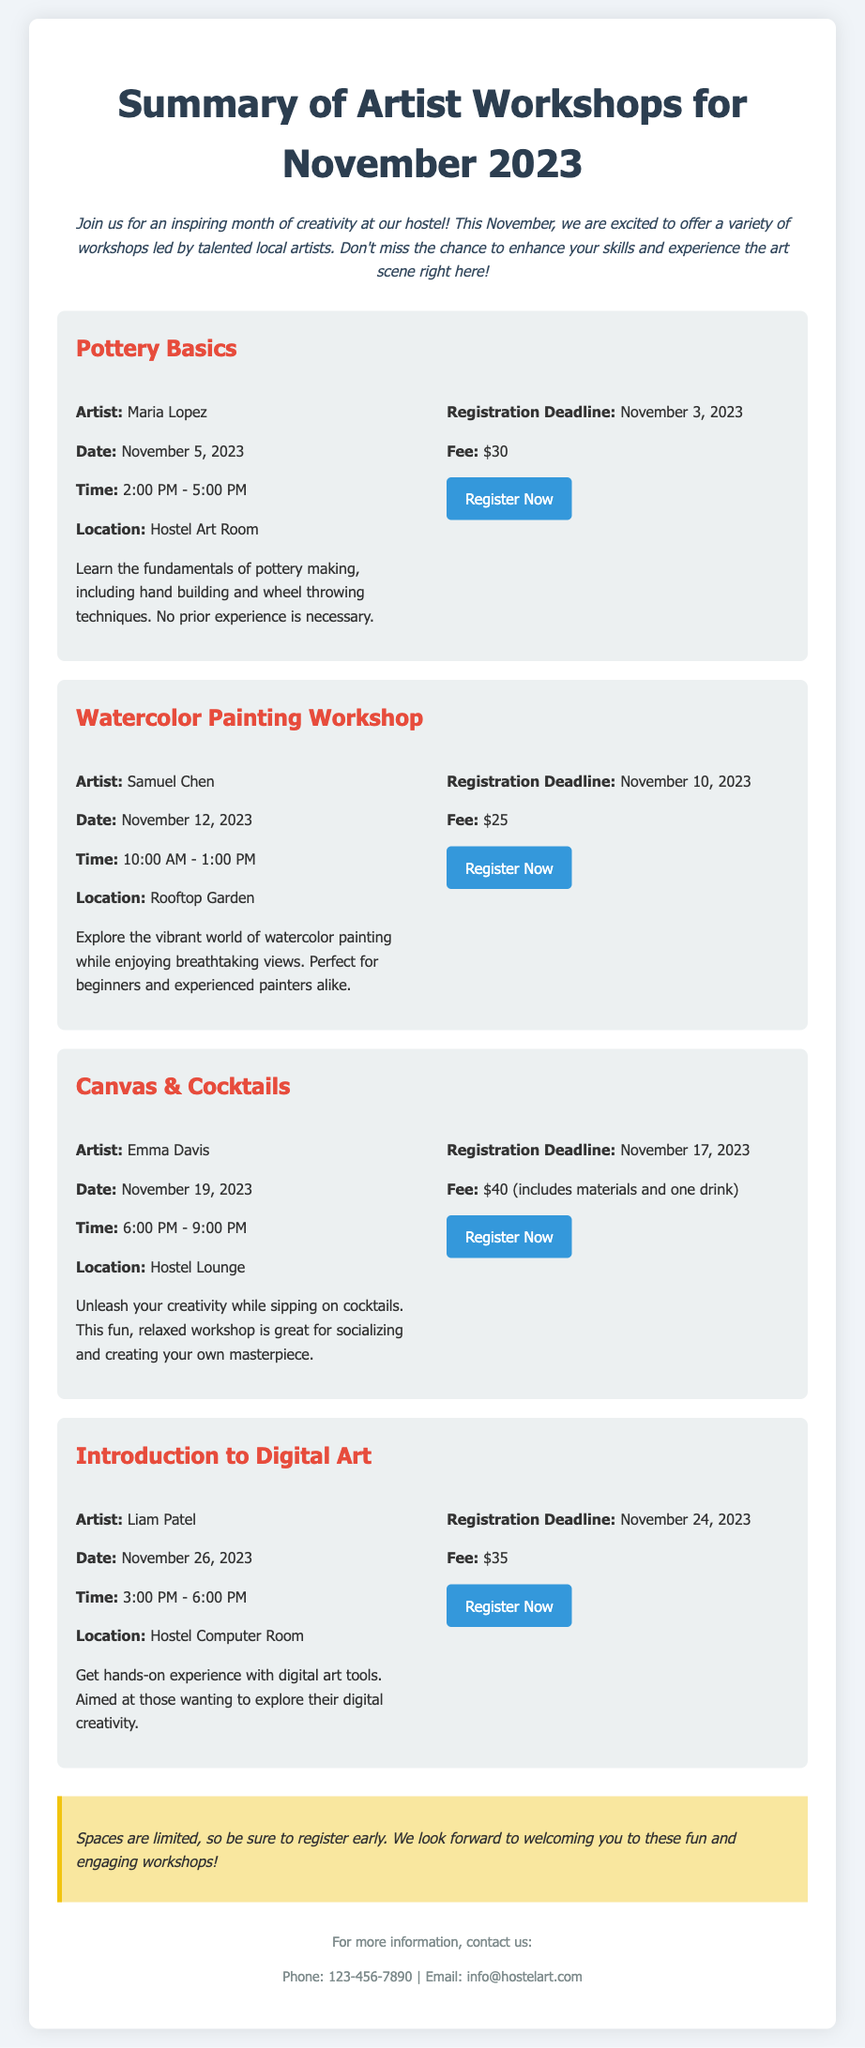What is the title of the first workshop? The title of the first workshop mentioned in the document is "Pottery Basics."
Answer: Pottery Basics Who is the instructor for the Watercolor Painting Workshop? The instructor for the Watercolor Painting Workshop is Samuel Chen.
Answer: Samuel Chen What is the registration deadline for the Canvas & Cocktails workshop? The registration deadline for the Canvas & Cocktails workshop is November 17, 2023.
Answer: November 17, 2023 How much does the Introduction to Digital Art workshop cost? The fee for the Introduction to Digital Art workshop is $35.
Answer: $35 What day of the week is the Pottery Basics workshop scheduled? The Pottery Basics workshop is scheduled for November 5, 2023, which is a Sunday.
Answer: Sunday How many workshops are available in November? There are four workshops available in November.
Answer: Four What time does the Watercolor Painting Workshop start? The Watercolor Painting Workshop starts at 10:00 AM.
Answer: 10:00 AM In which location will the Canvas & Cocktails workshop take place? The Canvas & Cocktails workshop will take place in the Hostel Lounge.
Answer: Hostel Lounge What is mentioned at the end of the document regarding registration? The note at the end mentions that spaces are limited, encouraging early registration.
Answer: Spaces are limited 